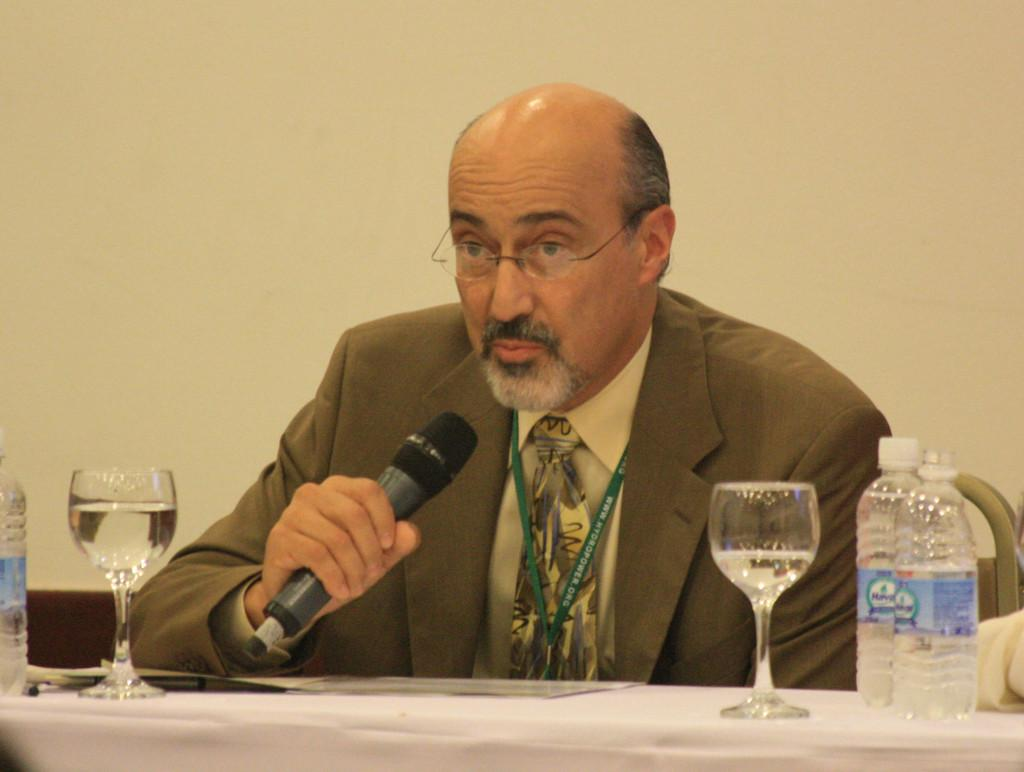What is the man in the image doing? The man is seated and speaking with the help of a microphone. What objects are on the table in the image? There are glasses and water bottles on the table in the image. What type of winter clothing is the man wearing in the image? There is no mention of winter clothing or any specific season in the image, so it cannot be determined from the image. 